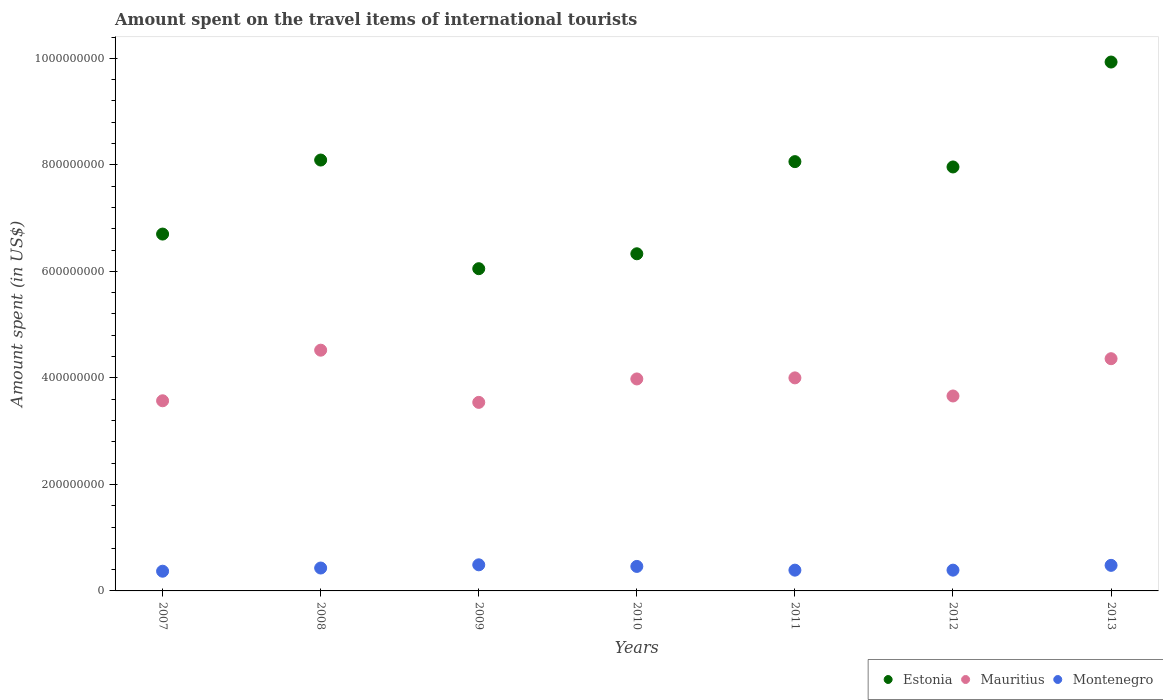How many different coloured dotlines are there?
Make the answer very short. 3. What is the amount spent on the travel items of international tourists in Estonia in 2009?
Your answer should be compact. 6.05e+08. Across all years, what is the maximum amount spent on the travel items of international tourists in Mauritius?
Ensure brevity in your answer.  4.52e+08. Across all years, what is the minimum amount spent on the travel items of international tourists in Mauritius?
Provide a short and direct response. 3.54e+08. In which year was the amount spent on the travel items of international tourists in Estonia maximum?
Provide a short and direct response. 2013. In which year was the amount spent on the travel items of international tourists in Mauritius minimum?
Your response must be concise. 2009. What is the total amount spent on the travel items of international tourists in Montenegro in the graph?
Your answer should be compact. 3.01e+08. What is the difference between the amount spent on the travel items of international tourists in Mauritius in 2010 and that in 2012?
Make the answer very short. 3.20e+07. What is the difference between the amount spent on the travel items of international tourists in Estonia in 2012 and the amount spent on the travel items of international tourists in Mauritius in 2008?
Make the answer very short. 3.44e+08. What is the average amount spent on the travel items of international tourists in Mauritius per year?
Your response must be concise. 3.95e+08. In the year 2007, what is the difference between the amount spent on the travel items of international tourists in Estonia and amount spent on the travel items of international tourists in Mauritius?
Provide a short and direct response. 3.13e+08. In how many years, is the amount spent on the travel items of international tourists in Estonia greater than 720000000 US$?
Keep it short and to the point. 4. What is the ratio of the amount spent on the travel items of international tourists in Mauritius in 2011 to that in 2013?
Your answer should be compact. 0.92. Is the amount spent on the travel items of international tourists in Montenegro in 2007 less than that in 2012?
Offer a very short reply. Yes. Is the difference between the amount spent on the travel items of international tourists in Estonia in 2009 and 2010 greater than the difference between the amount spent on the travel items of international tourists in Mauritius in 2009 and 2010?
Your answer should be very brief. Yes. What is the difference between the highest and the second highest amount spent on the travel items of international tourists in Mauritius?
Offer a terse response. 1.60e+07. What is the difference between the highest and the lowest amount spent on the travel items of international tourists in Mauritius?
Your answer should be compact. 9.80e+07. In how many years, is the amount spent on the travel items of international tourists in Montenegro greater than the average amount spent on the travel items of international tourists in Montenegro taken over all years?
Your response must be concise. 3. Is it the case that in every year, the sum of the amount spent on the travel items of international tourists in Estonia and amount spent on the travel items of international tourists in Montenegro  is greater than the amount spent on the travel items of international tourists in Mauritius?
Your answer should be very brief. Yes. Does the amount spent on the travel items of international tourists in Mauritius monotonically increase over the years?
Your answer should be very brief. No. How many dotlines are there?
Your answer should be compact. 3. Does the graph contain grids?
Make the answer very short. No. How many legend labels are there?
Your answer should be very brief. 3. What is the title of the graph?
Your answer should be compact. Amount spent on the travel items of international tourists. What is the label or title of the Y-axis?
Give a very brief answer. Amount spent (in US$). What is the Amount spent (in US$) of Estonia in 2007?
Keep it short and to the point. 6.70e+08. What is the Amount spent (in US$) of Mauritius in 2007?
Ensure brevity in your answer.  3.57e+08. What is the Amount spent (in US$) in Montenegro in 2007?
Keep it short and to the point. 3.70e+07. What is the Amount spent (in US$) of Estonia in 2008?
Keep it short and to the point. 8.09e+08. What is the Amount spent (in US$) in Mauritius in 2008?
Provide a short and direct response. 4.52e+08. What is the Amount spent (in US$) of Montenegro in 2008?
Provide a succinct answer. 4.30e+07. What is the Amount spent (in US$) in Estonia in 2009?
Your answer should be compact. 6.05e+08. What is the Amount spent (in US$) in Mauritius in 2009?
Ensure brevity in your answer.  3.54e+08. What is the Amount spent (in US$) of Montenegro in 2009?
Provide a short and direct response. 4.90e+07. What is the Amount spent (in US$) in Estonia in 2010?
Provide a succinct answer. 6.33e+08. What is the Amount spent (in US$) in Mauritius in 2010?
Offer a terse response. 3.98e+08. What is the Amount spent (in US$) in Montenegro in 2010?
Your answer should be compact. 4.60e+07. What is the Amount spent (in US$) of Estonia in 2011?
Offer a very short reply. 8.06e+08. What is the Amount spent (in US$) of Mauritius in 2011?
Make the answer very short. 4.00e+08. What is the Amount spent (in US$) in Montenegro in 2011?
Offer a very short reply. 3.90e+07. What is the Amount spent (in US$) of Estonia in 2012?
Your answer should be compact. 7.96e+08. What is the Amount spent (in US$) in Mauritius in 2012?
Offer a very short reply. 3.66e+08. What is the Amount spent (in US$) in Montenegro in 2012?
Offer a terse response. 3.90e+07. What is the Amount spent (in US$) of Estonia in 2013?
Ensure brevity in your answer.  9.93e+08. What is the Amount spent (in US$) of Mauritius in 2013?
Make the answer very short. 4.36e+08. What is the Amount spent (in US$) in Montenegro in 2013?
Provide a short and direct response. 4.80e+07. Across all years, what is the maximum Amount spent (in US$) in Estonia?
Your answer should be compact. 9.93e+08. Across all years, what is the maximum Amount spent (in US$) of Mauritius?
Keep it short and to the point. 4.52e+08. Across all years, what is the maximum Amount spent (in US$) in Montenegro?
Your response must be concise. 4.90e+07. Across all years, what is the minimum Amount spent (in US$) in Estonia?
Offer a terse response. 6.05e+08. Across all years, what is the minimum Amount spent (in US$) of Mauritius?
Ensure brevity in your answer.  3.54e+08. Across all years, what is the minimum Amount spent (in US$) in Montenegro?
Ensure brevity in your answer.  3.70e+07. What is the total Amount spent (in US$) in Estonia in the graph?
Offer a very short reply. 5.31e+09. What is the total Amount spent (in US$) in Mauritius in the graph?
Offer a terse response. 2.76e+09. What is the total Amount spent (in US$) in Montenegro in the graph?
Your answer should be compact. 3.01e+08. What is the difference between the Amount spent (in US$) in Estonia in 2007 and that in 2008?
Keep it short and to the point. -1.39e+08. What is the difference between the Amount spent (in US$) in Mauritius in 2007 and that in 2008?
Offer a terse response. -9.50e+07. What is the difference between the Amount spent (in US$) in Montenegro in 2007 and that in 2008?
Your answer should be very brief. -6.00e+06. What is the difference between the Amount spent (in US$) in Estonia in 2007 and that in 2009?
Your response must be concise. 6.50e+07. What is the difference between the Amount spent (in US$) of Mauritius in 2007 and that in 2009?
Your response must be concise. 3.00e+06. What is the difference between the Amount spent (in US$) in Montenegro in 2007 and that in 2009?
Give a very brief answer. -1.20e+07. What is the difference between the Amount spent (in US$) of Estonia in 2007 and that in 2010?
Make the answer very short. 3.70e+07. What is the difference between the Amount spent (in US$) of Mauritius in 2007 and that in 2010?
Give a very brief answer. -4.10e+07. What is the difference between the Amount spent (in US$) in Montenegro in 2007 and that in 2010?
Your answer should be compact. -9.00e+06. What is the difference between the Amount spent (in US$) in Estonia in 2007 and that in 2011?
Ensure brevity in your answer.  -1.36e+08. What is the difference between the Amount spent (in US$) in Mauritius in 2007 and that in 2011?
Keep it short and to the point. -4.30e+07. What is the difference between the Amount spent (in US$) of Estonia in 2007 and that in 2012?
Offer a terse response. -1.26e+08. What is the difference between the Amount spent (in US$) in Mauritius in 2007 and that in 2012?
Offer a terse response. -9.00e+06. What is the difference between the Amount spent (in US$) in Estonia in 2007 and that in 2013?
Ensure brevity in your answer.  -3.23e+08. What is the difference between the Amount spent (in US$) in Mauritius in 2007 and that in 2013?
Keep it short and to the point. -7.90e+07. What is the difference between the Amount spent (in US$) in Montenegro in 2007 and that in 2013?
Give a very brief answer. -1.10e+07. What is the difference between the Amount spent (in US$) of Estonia in 2008 and that in 2009?
Give a very brief answer. 2.04e+08. What is the difference between the Amount spent (in US$) of Mauritius in 2008 and that in 2009?
Offer a terse response. 9.80e+07. What is the difference between the Amount spent (in US$) of Montenegro in 2008 and that in 2009?
Offer a terse response. -6.00e+06. What is the difference between the Amount spent (in US$) of Estonia in 2008 and that in 2010?
Keep it short and to the point. 1.76e+08. What is the difference between the Amount spent (in US$) in Mauritius in 2008 and that in 2010?
Your response must be concise. 5.40e+07. What is the difference between the Amount spent (in US$) in Montenegro in 2008 and that in 2010?
Your answer should be very brief. -3.00e+06. What is the difference between the Amount spent (in US$) of Estonia in 2008 and that in 2011?
Provide a short and direct response. 3.00e+06. What is the difference between the Amount spent (in US$) in Mauritius in 2008 and that in 2011?
Offer a terse response. 5.20e+07. What is the difference between the Amount spent (in US$) of Estonia in 2008 and that in 2012?
Make the answer very short. 1.30e+07. What is the difference between the Amount spent (in US$) in Mauritius in 2008 and that in 2012?
Offer a terse response. 8.60e+07. What is the difference between the Amount spent (in US$) of Montenegro in 2008 and that in 2012?
Ensure brevity in your answer.  4.00e+06. What is the difference between the Amount spent (in US$) of Estonia in 2008 and that in 2013?
Keep it short and to the point. -1.84e+08. What is the difference between the Amount spent (in US$) in Mauritius in 2008 and that in 2013?
Your answer should be compact. 1.60e+07. What is the difference between the Amount spent (in US$) of Montenegro in 2008 and that in 2013?
Offer a very short reply. -5.00e+06. What is the difference between the Amount spent (in US$) in Estonia in 2009 and that in 2010?
Your response must be concise. -2.80e+07. What is the difference between the Amount spent (in US$) of Mauritius in 2009 and that in 2010?
Make the answer very short. -4.40e+07. What is the difference between the Amount spent (in US$) of Montenegro in 2009 and that in 2010?
Your answer should be very brief. 3.00e+06. What is the difference between the Amount spent (in US$) in Estonia in 2009 and that in 2011?
Ensure brevity in your answer.  -2.01e+08. What is the difference between the Amount spent (in US$) in Mauritius in 2009 and that in 2011?
Your response must be concise. -4.60e+07. What is the difference between the Amount spent (in US$) in Montenegro in 2009 and that in 2011?
Keep it short and to the point. 1.00e+07. What is the difference between the Amount spent (in US$) in Estonia in 2009 and that in 2012?
Keep it short and to the point. -1.91e+08. What is the difference between the Amount spent (in US$) of Mauritius in 2009 and that in 2012?
Ensure brevity in your answer.  -1.20e+07. What is the difference between the Amount spent (in US$) in Montenegro in 2009 and that in 2012?
Your answer should be compact. 1.00e+07. What is the difference between the Amount spent (in US$) of Estonia in 2009 and that in 2013?
Ensure brevity in your answer.  -3.88e+08. What is the difference between the Amount spent (in US$) of Mauritius in 2009 and that in 2013?
Give a very brief answer. -8.20e+07. What is the difference between the Amount spent (in US$) of Montenegro in 2009 and that in 2013?
Offer a terse response. 1.00e+06. What is the difference between the Amount spent (in US$) of Estonia in 2010 and that in 2011?
Your answer should be compact. -1.73e+08. What is the difference between the Amount spent (in US$) of Mauritius in 2010 and that in 2011?
Your answer should be compact. -2.00e+06. What is the difference between the Amount spent (in US$) of Montenegro in 2010 and that in 2011?
Provide a short and direct response. 7.00e+06. What is the difference between the Amount spent (in US$) in Estonia in 2010 and that in 2012?
Your response must be concise. -1.63e+08. What is the difference between the Amount spent (in US$) in Mauritius in 2010 and that in 2012?
Provide a short and direct response. 3.20e+07. What is the difference between the Amount spent (in US$) in Estonia in 2010 and that in 2013?
Your answer should be very brief. -3.60e+08. What is the difference between the Amount spent (in US$) of Mauritius in 2010 and that in 2013?
Offer a terse response. -3.80e+07. What is the difference between the Amount spent (in US$) in Montenegro in 2010 and that in 2013?
Offer a very short reply. -2.00e+06. What is the difference between the Amount spent (in US$) in Mauritius in 2011 and that in 2012?
Give a very brief answer. 3.40e+07. What is the difference between the Amount spent (in US$) of Estonia in 2011 and that in 2013?
Your answer should be compact. -1.87e+08. What is the difference between the Amount spent (in US$) in Mauritius in 2011 and that in 2013?
Make the answer very short. -3.60e+07. What is the difference between the Amount spent (in US$) in Montenegro in 2011 and that in 2013?
Your answer should be compact. -9.00e+06. What is the difference between the Amount spent (in US$) in Estonia in 2012 and that in 2013?
Make the answer very short. -1.97e+08. What is the difference between the Amount spent (in US$) in Mauritius in 2012 and that in 2013?
Make the answer very short. -7.00e+07. What is the difference between the Amount spent (in US$) of Montenegro in 2012 and that in 2013?
Offer a very short reply. -9.00e+06. What is the difference between the Amount spent (in US$) in Estonia in 2007 and the Amount spent (in US$) in Mauritius in 2008?
Offer a terse response. 2.18e+08. What is the difference between the Amount spent (in US$) of Estonia in 2007 and the Amount spent (in US$) of Montenegro in 2008?
Keep it short and to the point. 6.27e+08. What is the difference between the Amount spent (in US$) in Mauritius in 2007 and the Amount spent (in US$) in Montenegro in 2008?
Keep it short and to the point. 3.14e+08. What is the difference between the Amount spent (in US$) in Estonia in 2007 and the Amount spent (in US$) in Mauritius in 2009?
Give a very brief answer. 3.16e+08. What is the difference between the Amount spent (in US$) of Estonia in 2007 and the Amount spent (in US$) of Montenegro in 2009?
Provide a short and direct response. 6.21e+08. What is the difference between the Amount spent (in US$) in Mauritius in 2007 and the Amount spent (in US$) in Montenegro in 2009?
Your response must be concise. 3.08e+08. What is the difference between the Amount spent (in US$) of Estonia in 2007 and the Amount spent (in US$) of Mauritius in 2010?
Your answer should be very brief. 2.72e+08. What is the difference between the Amount spent (in US$) of Estonia in 2007 and the Amount spent (in US$) of Montenegro in 2010?
Offer a very short reply. 6.24e+08. What is the difference between the Amount spent (in US$) of Mauritius in 2007 and the Amount spent (in US$) of Montenegro in 2010?
Ensure brevity in your answer.  3.11e+08. What is the difference between the Amount spent (in US$) in Estonia in 2007 and the Amount spent (in US$) in Mauritius in 2011?
Your answer should be compact. 2.70e+08. What is the difference between the Amount spent (in US$) in Estonia in 2007 and the Amount spent (in US$) in Montenegro in 2011?
Your answer should be very brief. 6.31e+08. What is the difference between the Amount spent (in US$) of Mauritius in 2007 and the Amount spent (in US$) of Montenegro in 2011?
Your response must be concise. 3.18e+08. What is the difference between the Amount spent (in US$) in Estonia in 2007 and the Amount spent (in US$) in Mauritius in 2012?
Give a very brief answer. 3.04e+08. What is the difference between the Amount spent (in US$) in Estonia in 2007 and the Amount spent (in US$) in Montenegro in 2012?
Your answer should be very brief. 6.31e+08. What is the difference between the Amount spent (in US$) in Mauritius in 2007 and the Amount spent (in US$) in Montenegro in 2012?
Provide a short and direct response. 3.18e+08. What is the difference between the Amount spent (in US$) in Estonia in 2007 and the Amount spent (in US$) in Mauritius in 2013?
Keep it short and to the point. 2.34e+08. What is the difference between the Amount spent (in US$) in Estonia in 2007 and the Amount spent (in US$) in Montenegro in 2013?
Keep it short and to the point. 6.22e+08. What is the difference between the Amount spent (in US$) of Mauritius in 2007 and the Amount spent (in US$) of Montenegro in 2013?
Provide a succinct answer. 3.09e+08. What is the difference between the Amount spent (in US$) of Estonia in 2008 and the Amount spent (in US$) of Mauritius in 2009?
Provide a short and direct response. 4.55e+08. What is the difference between the Amount spent (in US$) in Estonia in 2008 and the Amount spent (in US$) in Montenegro in 2009?
Offer a very short reply. 7.60e+08. What is the difference between the Amount spent (in US$) of Mauritius in 2008 and the Amount spent (in US$) of Montenegro in 2009?
Your answer should be very brief. 4.03e+08. What is the difference between the Amount spent (in US$) of Estonia in 2008 and the Amount spent (in US$) of Mauritius in 2010?
Make the answer very short. 4.11e+08. What is the difference between the Amount spent (in US$) of Estonia in 2008 and the Amount spent (in US$) of Montenegro in 2010?
Your answer should be compact. 7.63e+08. What is the difference between the Amount spent (in US$) of Mauritius in 2008 and the Amount spent (in US$) of Montenegro in 2010?
Provide a succinct answer. 4.06e+08. What is the difference between the Amount spent (in US$) in Estonia in 2008 and the Amount spent (in US$) in Mauritius in 2011?
Offer a terse response. 4.09e+08. What is the difference between the Amount spent (in US$) in Estonia in 2008 and the Amount spent (in US$) in Montenegro in 2011?
Offer a terse response. 7.70e+08. What is the difference between the Amount spent (in US$) of Mauritius in 2008 and the Amount spent (in US$) of Montenegro in 2011?
Make the answer very short. 4.13e+08. What is the difference between the Amount spent (in US$) in Estonia in 2008 and the Amount spent (in US$) in Mauritius in 2012?
Ensure brevity in your answer.  4.43e+08. What is the difference between the Amount spent (in US$) of Estonia in 2008 and the Amount spent (in US$) of Montenegro in 2012?
Your response must be concise. 7.70e+08. What is the difference between the Amount spent (in US$) of Mauritius in 2008 and the Amount spent (in US$) of Montenegro in 2012?
Your answer should be compact. 4.13e+08. What is the difference between the Amount spent (in US$) of Estonia in 2008 and the Amount spent (in US$) of Mauritius in 2013?
Give a very brief answer. 3.73e+08. What is the difference between the Amount spent (in US$) of Estonia in 2008 and the Amount spent (in US$) of Montenegro in 2013?
Provide a short and direct response. 7.61e+08. What is the difference between the Amount spent (in US$) of Mauritius in 2008 and the Amount spent (in US$) of Montenegro in 2013?
Keep it short and to the point. 4.04e+08. What is the difference between the Amount spent (in US$) of Estonia in 2009 and the Amount spent (in US$) of Mauritius in 2010?
Your response must be concise. 2.07e+08. What is the difference between the Amount spent (in US$) of Estonia in 2009 and the Amount spent (in US$) of Montenegro in 2010?
Your response must be concise. 5.59e+08. What is the difference between the Amount spent (in US$) in Mauritius in 2009 and the Amount spent (in US$) in Montenegro in 2010?
Your answer should be compact. 3.08e+08. What is the difference between the Amount spent (in US$) of Estonia in 2009 and the Amount spent (in US$) of Mauritius in 2011?
Provide a succinct answer. 2.05e+08. What is the difference between the Amount spent (in US$) in Estonia in 2009 and the Amount spent (in US$) in Montenegro in 2011?
Your answer should be very brief. 5.66e+08. What is the difference between the Amount spent (in US$) of Mauritius in 2009 and the Amount spent (in US$) of Montenegro in 2011?
Keep it short and to the point. 3.15e+08. What is the difference between the Amount spent (in US$) in Estonia in 2009 and the Amount spent (in US$) in Mauritius in 2012?
Ensure brevity in your answer.  2.39e+08. What is the difference between the Amount spent (in US$) in Estonia in 2009 and the Amount spent (in US$) in Montenegro in 2012?
Provide a short and direct response. 5.66e+08. What is the difference between the Amount spent (in US$) in Mauritius in 2009 and the Amount spent (in US$) in Montenegro in 2012?
Provide a short and direct response. 3.15e+08. What is the difference between the Amount spent (in US$) in Estonia in 2009 and the Amount spent (in US$) in Mauritius in 2013?
Make the answer very short. 1.69e+08. What is the difference between the Amount spent (in US$) of Estonia in 2009 and the Amount spent (in US$) of Montenegro in 2013?
Your answer should be compact. 5.57e+08. What is the difference between the Amount spent (in US$) in Mauritius in 2009 and the Amount spent (in US$) in Montenegro in 2013?
Give a very brief answer. 3.06e+08. What is the difference between the Amount spent (in US$) of Estonia in 2010 and the Amount spent (in US$) of Mauritius in 2011?
Make the answer very short. 2.33e+08. What is the difference between the Amount spent (in US$) of Estonia in 2010 and the Amount spent (in US$) of Montenegro in 2011?
Ensure brevity in your answer.  5.94e+08. What is the difference between the Amount spent (in US$) of Mauritius in 2010 and the Amount spent (in US$) of Montenegro in 2011?
Give a very brief answer. 3.59e+08. What is the difference between the Amount spent (in US$) of Estonia in 2010 and the Amount spent (in US$) of Mauritius in 2012?
Provide a short and direct response. 2.67e+08. What is the difference between the Amount spent (in US$) of Estonia in 2010 and the Amount spent (in US$) of Montenegro in 2012?
Keep it short and to the point. 5.94e+08. What is the difference between the Amount spent (in US$) of Mauritius in 2010 and the Amount spent (in US$) of Montenegro in 2012?
Make the answer very short. 3.59e+08. What is the difference between the Amount spent (in US$) of Estonia in 2010 and the Amount spent (in US$) of Mauritius in 2013?
Give a very brief answer. 1.97e+08. What is the difference between the Amount spent (in US$) of Estonia in 2010 and the Amount spent (in US$) of Montenegro in 2013?
Your response must be concise. 5.85e+08. What is the difference between the Amount spent (in US$) in Mauritius in 2010 and the Amount spent (in US$) in Montenegro in 2013?
Offer a terse response. 3.50e+08. What is the difference between the Amount spent (in US$) in Estonia in 2011 and the Amount spent (in US$) in Mauritius in 2012?
Give a very brief answer. 4.40e+08. What is the difference between the Amount spent (in US$) in Estonia in 2011 and the Amount spent (in US$) in Montenegro in 2012?
Make the answer very short. 7.67e+08. What is the difference between the Amount spent (in US$) in Mauritius in 2011 and the Amount spent (in US$) in Montenegro in 2012?
Offer a terse response. 3.61e+08. What is the difference between the Amount spent (in US$) in Estonia in 2011 and the Amount spent (in US$) in Mauritius in 2013?
Make the answer very short. 3.70e+08. What is the difference between the Amount spent (in US$) in Estonia in 2011 and the Amount spent (in US$) in Montenegro in 2013?
Offer a terse response. 7.58e+08. What is the difference between the Amount spent (in US$) of Mauritius in 2011 and the Amount spent (in US$) of Montenegro in 2013?
Your answer should be compact. 3.52e+08. What is the difference between the Amount spent (in US$) in Estonia in 2012 and the Amount spent (in US$) in Mauritius in 2013?
Keep it short and to the point. 3.60e+08. What is the difference between the Amount spent (in US$) of Estonia in 2012 and the Amount spent (in US$) of Montenegro in 2013?
Your answer should be compact. 7.48e+08. What is the difference between the Amount spent (in US$) of Mauritius in 2012 and the Amount spent (in US$) of Montenegro in 2013?
Ensure brevity in your answer.  3.18e+08. What is the average Amount spent (in US$) of Estonia per year?
Keep it short and to the point. 7.59e+08. What is the average Amount spent (in US$) in Mauritius per year?
Give a very brief answer. 3.95e+08. What is the average Amount spent (in US$) of Montenegro per year?
Keep it short and to the point. 4.30e+07. In the year 2007, what is the difference between the Amount spent (in US$) in Estonia and Amount spent (in US$) in Mauritius?
Provide a succinct answer. 3.13e+08. In the year 2007, what is the difference between the Amount spent (in US$) in Estonia and Amount spent (in US$) in Montenegro?
Offer a terse response. 6.33e+08. In the year 2007, what is the difference between the Amount spent (in US$) in Mauritius and Amount spent (in US$) in Montenegro?
Your answer should be very brief. 3.20e+08. In the year 2008, what is the difference between the Amount spent (in US$) of Estonia and Amount spent (in US$) of Mauritius?
Provide a succinct answer. 3.57e+08. In the year 2008, what is the difference between the Amount spent (in US$) of Estonia and Amount spent (in US$) of Montenegro?
Offer a very short reply. 7.66e+08. In the year 2008, what is the difference between the Amount spent (in US$) of Mauritius and Amount spent (in US$) of Montenegro?
Give a very brief answer. 4.09e+08. In the year 2009, what is the difference between the Amount spent (in US$) of Estonia and Amount spent (in US$) of Mauritius?
Offer a very short reply. 2.51e+08. In the year 2009, what is the difference between the Amount spent (in US$) of Estonia and Amount spent (in US$) of Montenegro?
Keep it short and to the point. 5.56e+08. In the year 2009, what is the difference between the Amount spent (in US$) in Mauritius and Amount spent (in US$) in Montenegro?
Offer a very short reply. 3.05e+08. In the year 2010, what is the difference between the Amount spent (in US$) of Estonia and Amount spent (in US$) of Mauritius?
Offer a very short reply. 2.35e+08. In the year 2010, what is the difference between the Amount spent (in US$) of Estonia and Amount spent (in US$) of Montenegro?
Provide a short and direct response. 5.87e+08. In the year 2010, what is the difference between the Amount spent (in US$) in Mauritius and Amount spent (in US$) in Montenegro?
Provide a short and direct response. 3.52e+08. In the year 2011, what is the difference between the Amount spent (in US$) of Estonia and Amount spent (in US$) of Mauritius?
Your answer should be compact. 4.06e+08. In the year 2011, what is the difference between the Amount spent (in US$) of Estonia and Amount spent (in US$) of Montenegro?
Offer a terse response. 7.67e+08. In the year 2011, what is the difference between the Amount spent (in US$) of Mauritius and Amount spent (in US$) of Montenegro?
Provide a succinct answer. 3.61e+08. In the year 2012, what is the difference between the Amount spent (in US$) of Estonia and Amount spent (in US$) of Mauritius?
Keep it short and to the point. 4.30e+08. In the year 2012, what is the difference between the Amount spent (in US$) in Estonia and Amount spent (in US$) in Montenegro?
Your answer should be very brief. 7.57e+08. In the year 2012, what is the difference between the Amount spent (in US$) in Mauritius and Amount spent (in US$) in Montenegro?
Keep it short and to the point. 3.27e+08. In the year 2013, what is the difference between the Amount spent (in US$) of Estonia and Amount spent (in US$) of Mauritius?
Offer a terse response. 5.57e+08. In the year 2013, what is the difference between the Amount spent (in US$) of Estonia and Amount spent (in US$) of Montenegro?
Make the answer very short. 9.45e+08. In the year 2013, what is the difference between the Amount spent (in US$) of Mauritius and Amount spent (in US$) of Montenegro?
Your answer should be very brief. 3.88e+08. What is the ratio of the Amount spent (in US$) in Estonia in 2007 to that in 2008?
Ensure brevity in your answer.  0.83. What is the ratio of the Amount spent (in US$) of Mauritius in 2007 to that in 2008?
Offer a very short reply. 0.79. What is the ratio of the Amount spent (in US$) in Montenegro in 2007 to that in 2008?
Give a very brief answer. 0.86. What is the ratio of the Amount spent (in US$) in Estonia in 2007 to that in 2009?
Make the answer very short. 1.11. What is the ratio of the Amount spent (in US$) of Mauritius in 2007 to that in 2009?
Your answer should be very brief. 1.01. What is the ratio of the Amount spent (in US$) of Montenegro in 2007 to that in 2009?
Offer a terse response. 0.76. What is the ratio of the Amount spent (in US$) in Estonia in 2007 to that in 2010?
Make the answer very short. 1.06. What is the ratio of the Amount spent (in US$) of Mauritius in 2007 to that in 2010?
Ensure brevity in your answer.  0.9. What is the ratio of the Amount spent (in US$) of Montenegro in 2007 to that in 2010?
Provide a succinct answer. 0.8. What is the ratio of the Amount spent (in US$) in Estonia in 2007 to that in 2011?
Your response must be concise. 0.83. What is the ratio of the Amount spent (in US$) in Mauritius in 2007 to that in 2011?
Offer a very short reply. 0.89. What is the ratio of the Amount spent (in US$) of Montenegro in 2007 to that in 2011?
Make the answer very short. 0.95. What is the ratio of the Amount spent (in US$) of Estonia in 2007 to that in 2012?
Your response must be concise. 0.84. What is the ratio of the Amount spent (in US$) in Mauritius in 2007 to that in 2012?
Your answer should be compact. 0.98. What is the ratio of the Amount spent (in US$) in Montenegro in 2007 to that in 2012?
Ensure brevity in your answer.  0.95. What is the ratio of the Amount spent (in US$) of Estonia in 2007 to that in 2013?
Offer a terse response. 0.67. What is the ratio of the Amount spent (in US$) of Mauritius in 2007 to that in 2013?
Make the answer very short. 0.82. What is the ratio of the Amount spent (in US$) in Montenegro in 2007 to that in 2013?
Provide a succinct answer. 0.77. What is the ratio of the Amount spent (in US$) of Estonia in 2008 to that in 2009?
Give a very brief answer. 1.34. What is the ratio of the Amount spent (in US$) of Mauritius in 2008 to that in 2009?
Your response must be concise. 1.28. What is the ratio of the Amount spent (in US$) in Montenegro in 2008 to that in 2009?
Keep it short and to the point. 0.88. What is the ratio of the Amount spent (in US$) of Estonia in 2008 to that in 2010?
Offer a terse response. 1.28. What is the ratio of the Amount spent (in US$) of Mauritius in 2008 to that in 2010?
Make the answer very short. 1.14. What is the ratio of the Amount spent (in US$) in Montenegro in 2008 to that in 2010?
Offer a very short reply. 0.93. What is the ratio of the Amount spent (in US$) in Mauritius in 2008 to that in 2011?
Your answer should be compact. 1.13. What is the ratio of the Amount spent (in US$) in Montenegro in 2008 to that in 2011?
Your response must be concise. 1.1. What is the ratio of the Amount spent (in US$) in Estonia in 2008 to that in 2012?
Offer a terse response. 1.02. What is the ratio of the Amount spent (in US$) of Mauritius in 2008 to that in 2012?
Your response must be concise. 1.24. What is the ratio of the Amount spent (in US$) of Montenegro in 2008 to that in 2012?
Provide a short and direct response. 1.1. What is the ratio of the Amount spent (in US$) of Estonia in 2008 to that in 2013?
Offer a very short reply. 0.81. What is the ratio of the Amount spent (in US$) of Mauritius in 2008 to that in 2013?
Provide a succinct answer. 1.04. What is the ratio of the Amount spent (in US$) of Montenegro in 2008 to that in 2013?
Offer a very short reply. 0.9. What is the ratio of the Amount spent (in US$) in Estonia in 2009 to that in 2010?
Provide a short and direct response. 0.96. What is the ratio of the Amount spent (in US$) of Mauritius in 2009 to that in 2010?
Make the answer very short. 0.89. What is the ratio of the Amount spent (in US$) of Montenegro in 2009 to that in 2010?
Provide a succinct answer. 1.07. What is the ratio of the Amount spent (in US$) in Estonia in 2009 to that in 2011?
Provide a short and direct response. 0.75. What is the ratio of the Amount spent (in US$) in Mauritius in 2009 to that in 2011?
Give a very brief answer. 0.89. What is the ratio of the Amount spent (in US$) in Montenegro in 2009 to that in 2011?
Make the answer very short. 1.26. What is the ratio of the Amount spent (in US$) in Estonia in 2009 to that in 2012?
Ensure brevity in your answer.  0.76. What is the ratio of the Amount spent (in US$) in Mauritius in 2009 to that in 2012?
Ensure brevity in your answer.  0.97. What is the ratio of the Amount spent (in US$) in Montenegro in 2009 to that in 2012?
Your answer should be compact. 1.26. What is the ratio of the Amount spent (in US$) in Estonia in 2009 to that in 2013?
Offer a very short reply. 0.61. What is the ratio of the Amount spent (in US$) in Mauritius in 2009 to that in 2013?
Your response must be concise. 0.81. What is the ratio of the Amount spent (in US$) of Montenegro in 2009 to that in 2013?
Provide a succinct answer. 1.02. What is the ratio of the Amount spent (in US$) of Estonia in 2010 to that in 2011?
Your answer should be very brief. 0.79. What is the ratio of the Amount spent (in US$) in Montenegro in 2010 to that in 2011?
Keep it short and to the point. 1.18. What is the ratio of the Amount spent (in US$) in Estonia in 2010 to that in 2012?
Ensure brevity in your answer.  0.8. What is the ratio of the Amount spent (in US$) of Mauritius in 2010 to that in 2012?
Your answer should be compact. 1.09. What is the ratio of the Amount spent (in US$) of Montenegro in 2010 to that in 2012?
Your answer should be compact. 1.18. What is the ratio of the Amount spent (in US$) of Estonia in 2010 to that in 2013?
Your response must be concise. 0.64. What is the ratio of the Amount spent (in US$) of Mauritius in 2010 to that in 2013?
Give a very brief answer. 0.91. What is the ratio of the Amount spent (in US$) in Montenegro in 2010 to that in 2013?
Provide a short and direct response. 0.96. What is the ratio of the Amount spent (in US$) of Estonia in 2011 to that in 2012?
Ensure brevity in your answer.  1.01. What is the ratio of the Amount spent (in US$) of Mauritius in 2011 to that in 2012?
Give a very brief answer. 1.09. What is the ratio of the Amount spent (in US$) of Montenegro in 2011 to that in 2012?
Make the answer very short. 1. What is the ratio of the Amount spent (in US$) of Estonia in 2011 to that in 2013?
Give a very brief answer. 0.81. What is the ratio of the Amount spent (in US$) in Mauritius in 2011 to that in 2013?
Offer a very short reply. 0.92. What is the ratio of the Amount spent (in US$) of Montenegro in 2011 to that in 2013?
Ensure brevity in your answer.  0.81. What is the ratio of the Amount spent (in US$) in Estonia in 2012 to that in 2013?
Provide a short and direct response. 0.8. What is the ratio of the Amount spent (in US$) of Mauritius in 2012 to that in 2013?
Keep it short and to the point. 0.84. What is the ratio of the Amount spent (in US$) in Montenegro in 2012 to that in 2013?
Provide a succinct answer. 0.81. What is the difference between the highest and the second highest Amount spent (in US$) in Estonia?
Keep it short and to the point. 1.84e+08. What is the difference between the highest and the second highest Amount spent (in US$) in Mauritius?
Offer a very short reply. 1.60e+07. What is the difference between the highest and the second highest Amount spent (in US$) of Montenegro?
Provide a short and direct response. 1.00e+06. What is the difference between the highest and the lowest Amount spent (in US$) of Estonia?
Provide a short and direct response. 3.88e+08. What is the difference between the highest and the lowest Amount spent (in US$) of Mauritius?
Your answer should be compact. 9.80e+07. What is the difference between the highest and the lowest Amount spent (in US$) of Montenegro?
Your answer should be compact. 1.20e+07. 